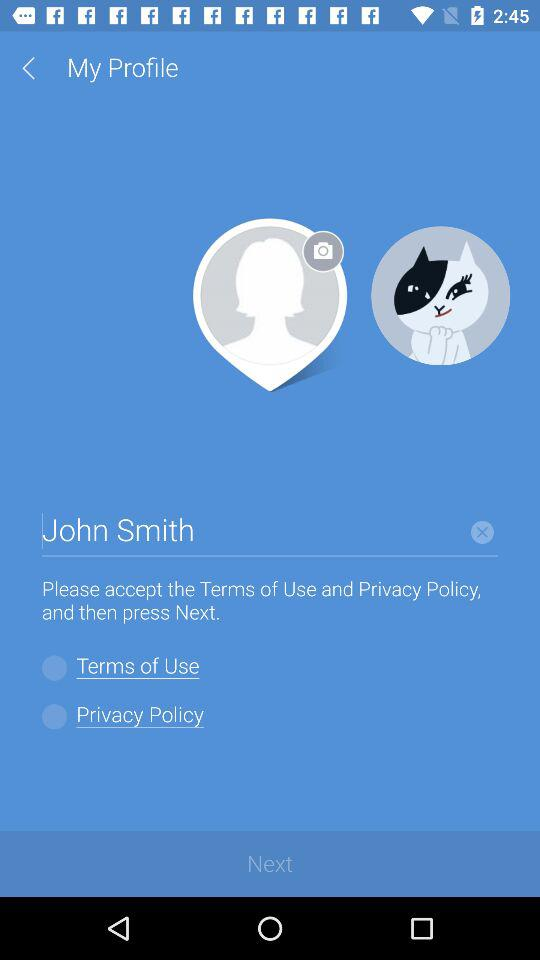What is the current state of "Privacy Policy"? The current state is off. 